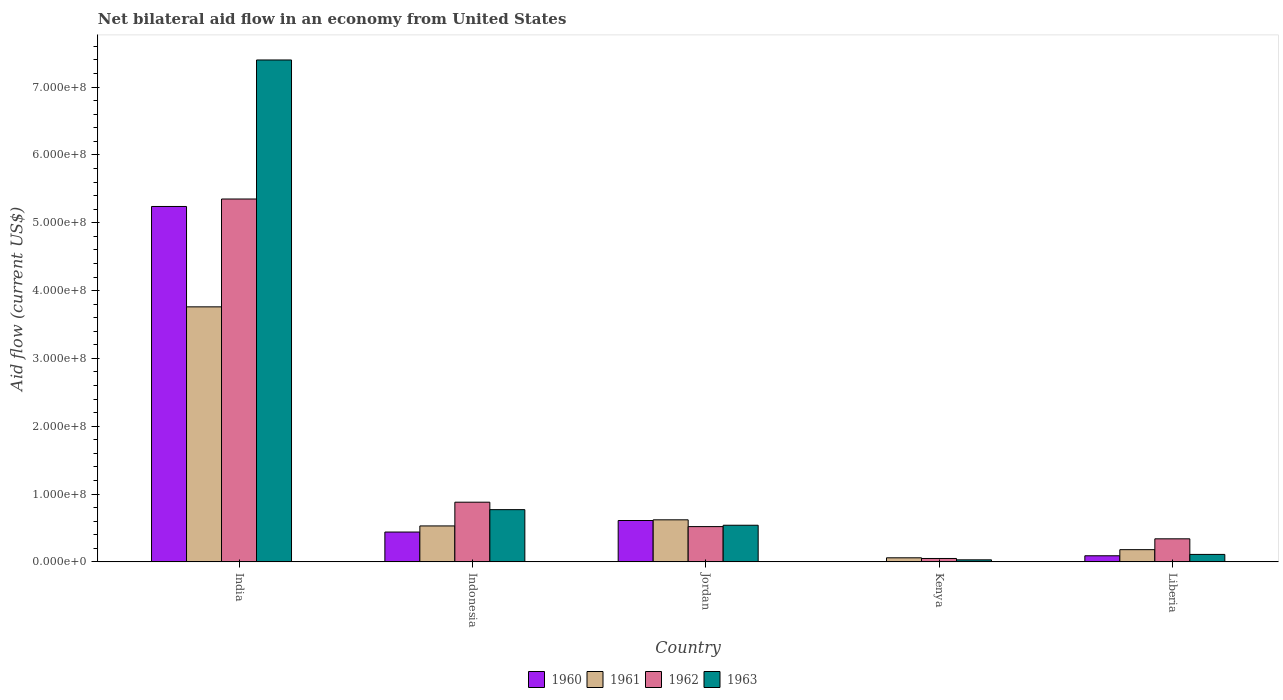How many groups of bars are there?
Keep it short and to the point. 5. Are the number of bars per tick equal to the number of legend labels?
Offer a very short reply. Yes. Are the number of bars on each tick of the X-axis equal?
Make the answer very short. Yes. How many bars are there on the 1st tick from the right?
Give a very brief answer. 4. What is the label of the 3rd group of bars from the left?
Keep it short and to the point. Jordan. What is the net bilateral aid flow in 1960 in India?
Your answer should be very brief. 5.24e+08. Across all countries, what is the maximum net bilateral aid flow in 1960?
Provide a succinct answer. 5.24e+08. Across all countries, what is the minimum net bilateral aid flow in 1962?
Provide a succinct answer. 5.00e+06. In which country was the net bilateral aid flow in 1961 maximum?
Keep it short and to the point. India. In which country was the net bilateral aid flow in 1962 minimum?
Make the answer very short. Kenya. What is the total net bilateral aid flow in 1962 in the graph?
Your answer should be very brief. 7.14e+08. What is the difference between the net bilateral aid flow in 1960 in India and that in Jordan?
Keep it short and to the point. 4.63e+08. What is the difference between the net bilateral aid flow in 1961 in Liberia and the net bilateral aid flow in 1962 in Jordan?
Offer a very short reply. -3.40e+07. What is the average net bilateral aid flow in 1963 per country?
Your answer should be compact. 1.77e+08. What is the difference between the net bilateral aid flow of/in 1962 and net bilateral aid flow of/in 1963 in Indonesia?
Offer a terse response. 1.10e+07. In how many countries, is the net bilateral aid flow in 1961 greater than 380000000 US$?
Keep it short and to the point. 0. What is the ratio of the net bilateral aid flow in 1961 in India to that in Liberia?
Provide a short and direct response. 20.89. Is the difference between the net bilateral aid flow in 1962 in India and Jordan greater than the difference between the net bilateral aid flow in 1963 in India and Jordan?
Provide a succinct answer. No. What is the difference between the highest and the second highest net bilateral aid flow in 1962?
Your answer should be very brief. 4.47e+08. What is the difference between the highest and the lowest net bilateral aid flow in 1963?
Your answer should be compact. 7.37e+08. In how many countries, is the net bilateral aid flow in 1960 greater than the average net bilateral aid flow in 1960 taken over all countries?
Provide a succinct answer. 1. Is the sum of the net bilateral aid flow in 1960 in Kenya and Liberia greater than the maximum net bilateral aid flow in 1962 across all countries?
Keep it short and to the point. No. Is it the case that in every country, the sum of the net bilateral aid flow in 1960 and net bilateral aid flow in 1961 is greater than the sum of net bilateral aid flow in 1963 and net bilateral aid flow in 1962?
Provide a succinct answer. No. What does the 4th bar from the left in Kenya represents?
Your response must be concise. 1963. Is it the case that in every country, the sum of the net bilateral aid flow in 1962 and net bilateral aid flow in 1961 is greater than the net bilateral aid flow in 1963?
Keep it short and to the point. Yes. Are all the bars in the graph horizontal?
Your response must be concise. No. What is the difference between two consecutive major ticks on the Y-axis?
Provide a short and direct response. 1.00e+08. Are the values on the major ticks of Y-axis written in scientific E-notation?
Make the answer very short. Yes. How many legend labels are there?
Give a very brief answer. 4. How are the legend labels stacked?
Provide a succinct answer. Horizontal. What is the title of the graph?
Your answer should be compact. Net bilateral aid flow in an economy from United States. What is the label or title of the X-axis?
Offer a terse response. Country. What is the label or title of the Y-axis?
Ensure brevity in your answer.  Aid flow (current US$). What is the Aid flow (current US$) of 1960 in India?
Your response must be concise. 5.24e+08. What is the Aid flow (current US$) of 1961 in India?
Provide a short and direct response. 3.76e+08. What is the Aid flow (current US$) of 1962 in India?
Provide a short and direct response. 5.35e+08. What is the Aid flow (current US$) in 1963 in India?
Make the answer very short. 7.40e+08. What is the Aid flow (current US$) in 1960 in Indonesia?
Offer a very short reply. 4.40e+07. What is the Aid flow (current US$) in 1961 in Indonesia?
Offer a very short reply. 5.30e+07. What is the Aid flow (current US$) of 1962 in Indonesia?
Make the answer very short. 8.80e+07. What is the Aid flow (current US$) in 1963 in Indonesia?
Your response must be concise. 7.70e+07. What is the Aid flow (current US$) in 1960 in Jordan?
Your answer should be compact. 6.10e+07. What is the Aid flow (current US$) of 1961 in Jordan?
Offer a terse response. 6.20e+07. What is the Aid flow (current US$) in 1962 in Jordan?
Offer a terse response. 5.20e+07. What is the Aid flow (current US$) in 1963 in Jordan?
Your answer should be very brief. 5.40e+07. What is the Aid flow (current US$) in 1960 in Kenya?
Provide a succinct answer. 4.80e+05. What is the Aid flow (current US$) in 1961 in Kenya?
Offer a very short reply. 6.00e+06. What is the Aid flow (current US$) of 1962 in Kenya?
Offer a very short reply. 5.00e+06. What is the Aid flow (current US$) of 1963 in Kenya?
Keep it short and to the point. 3.00e+06. What is the Aid flow (current US$) of 1960 in Liberia?
Your answer should be compact. 9.00e+06. What is the Aid flow (current US$) in 1961 in Liberia?
Your answer should be compact. 1.80e+07. What is the Aid flow (current US$) of 1962 in Liberia?
Make the answer very short. 3.40e+07. What is the Aid flow (current US$) of 1963 in Liberia?
Provide a succinct answer. 1.10e+07. Across all countries, what is the maximum Aid flow (current US$) of 1960?
Make the answer very short. 5.24e+08. Across all countries, what is the maximum Aid flow (current US$) of 1961?
Your response must be concise. 3.76e+08. Across all countries, what is the maximum Aid flow (current US$) in 1962?
Provide a short and direct response. 5.35e+08. Across all countries, what is the maximum Aid flow (current US$) of 1963?
Give a very brief answer. 7.40e+08. Across all countries, what is the minimum Aid flow (current US$) in 1961?
Provide a short and direct response. 6.00e+06. Across all countries, what is the minimum Aid flow (current US$) of 1963?
Provide a short and direct response. 3.00e+06. What is the total Aid flow (current US$) of 1960 in the graph?
Provide a short and direct response. 6.38e+08. What is the total Aid flow (current US$) in 1961 in the graph?
Give a very brief answer. 5.15e+08. What is the total Aid flow (current US$) in 1962 in the graph?
Your response must be concise. 7.14e+08. What is the total Aid flow (current US$) of 1963 in the graph?
Offer a terse response. 8.85e+08. What is the difference between the Aid flow (current US$) of 1960 in India and that in Indonesia?
Offer a very short reply. 4.80e+08. What is the difference between the Aid flow (current US$) of 1961 in India and that in Indonesia?
Provide a succinct answer. 3.23e+08. What is the difference between the Aid flow (current US$) in 1962 in India and that in Indonesia?
Provide a short and direct response. 4.47e+08. What is the difference between the Aid flow (current US$) in 1963 in India and that in Indonesia?
Offer a terse response. 6.63e+08. What is the difference between the Aid flow (current US$) in 1960 in India and that in Jordan?
Your answer should be very brief. 4.63e+08. What is the difference between the Aid flow (current US$) of 1961 in India and that in Jordan?
Offer a very short reply. 3.14e+08. What is the difference between the Aid flow (current US$) in 1962 in India and that in Jordan?
Your answer should be compact. 4.83e+08. What is the difference between the Aid flow (current US$) of 1963 in India and that in Jordan?
Provide a succinct answer. 6.86e+08. What is the difference between the Aid flow (current US$) in 1960 in India and that in Kenya?
Give a very brief answer. 5.24e+08. What is the difference between the Aid flow (current US$) in 1961 in India and that in Kenya?
Your response must be concise. 3.70e+08. What is the difference between the Aid flow (current US$) of 1962 in India and that in Kenya?
Ensure brevity in your answer.  5.30e+08. What is the difference between the Aid flow (current US$) of 1963 in India and that in Kenya?
Provide a succinct answer. 7.37e+08. What is the difference between the Aid flow (current US$) in 1960 in India and that in Liberia?
Keep it short and to the point. 5.15e+08. What is the difference between the Aid flow (current US$) of 1961 in India and that in Liberia?
Provide a succinct answer. 3.58e+08. What is the difference between the Aid flow (current US$) of 1962 in India and that in Liberia?
Your answer should be compact. 5.01e+08. What is the difference between the Aid flow (current US$) in 1963 in India and that in Liberia?
Your answer should be very brief. 7.29e+08. What is the difference between the Aid flow (current US$) in 1960 in Indonesia and that in Jordan?
Offer a terse response. -1.70e+07. What is the difference between the Aid flow (current US$) in 1961 in Indonesia and that in Jordan?
Your answer should be compact. -9.00e+06. What is the difference between the Aid flow (current US$) of 1962 in Indonesia and that in Jordan?
Ensure brevity in your answer.  3.60e+07. What is the difference between the Aid flow (current US$) of 1963 in Indonesia and that in Jordan?
Offer a terse response. 2.30e+07. What is the difference between the Aid flow (current US$) of 1960 in Indonesia and that in Kenya?
Your answer should be very brief. 4.35e+07. What is the difference between the Aid flow (current US$) in 1961 in Indonesia and that in Kenya?
Your answer should be very brief. 4.70e+07. What is the difference between the Aid flow (current US$) in 1962 in Indonesia and that in Kenya?
Keep it short and to the point. 8.30e+07. What is the difference between the Aid flow (current US$) of 1963 in Indonesia and that in Kenya?
Your answer should be compact. 7.40e+07. What is the difference between the Aid flow (current US$) in 1960 in Indonesia and that in Liberia?
Keep it short and to the point. 3.50e+07. What is the difference between the Aid flow (current US$) in 1961 in Indonesia and that in Liberia?
Your response must be concise. 3.50e+07. What is the difference between the Aid flow (current US$) in 1962 in Indonesia and that in Liberia?
Give a very brief answer. 5.40e+07. What is the difference between the Aid flow (current US$) in 1963 in Indonesia and that in Liberia?
Your response must be concise. 6.60e+07. What is the difference between the Aid flow (current US$) of 1960 in Jordan and that in Kenya?
Make the answer very short. 6.05e+07. What is the difference between the Aid flow (current US$) in 1961 in Jordan and that in Kenya?
Offer a very short reply. 5.60e+07. What is the difference between the Aid flow (current US$) in 1962 in Jordan and that in Kenya?
Your answer should be compact. 4.70e+07. What is the difference between the Aid flow (current US$) of 1963 in Jordan and that in Kenya?
Make the answer very short. 5.10e+07. What is the difference between the Aid flow (current US$) of 1960 in Jordan and that in Liberia?
Offer a terse response. 5.20e+07. What is the difference between the Aid flow (current US$) of 1961 in Jordan and that in Liberia?
Offer a terse response. 4.40e+07. What is the difference between the Aid flow (current US$) of 1962 in Jordan and that in Liberia?
Your response must be concise. 1.80e+07. What is the difference between the Aid flow (current US$) in 1963 in Jordan and that in Liberia?
Your answer should be very brief. 4.30e+07. What is the difference between the Aid flow (current US$) in 1960 in Kenya and that in Liberia?
Make the answer very short. -8.52e+06. What is the difference between the Aid flow (current US$) of 1961 in Kenya and that in Liberia?
Offer a very short reply. -1.20e+07. What is the difference between the Aid flow (current US$) in 1962 in Kenya and that in Liberia?
Make the answer very short. -2.90e+07. What is the difference between the Aid flow (current US$) in 1963 in Kenya and that in Liberia?
Provide a short and direct response. -8.00e+06. What is the difference between the Aid flow (current US$) in 1960 in India and the Aid flow (current US$) in 1961 in Indonesia?
Provide a short and direct response. 4.71e+08. What is the difference between the Aid flow (current US$) of 1960 in India and the Aid flow (current US$) of 1962 in Indonesia?
Your answer should be compact. 4.36e+08. What is the difference between the Aid flow (current US$) in 1960 in India and the Aid flow (current US$) in 1963 in Indonesia?
Give a very brief answer. 4.47e+08. What is the difference between the Aid flow (current US$) in 1961 in India and the Aid flow (current US$) in 1962 in Indonesia?
Make the answer very short. 2.88e+08. What is the difference between the Aid flow (current US$) of 1961 in India and the Aid flow (current US$) of 1963 in Indonesia?
Offer a terse response. 2.99e+08. What is the difference between the Aid flow (current US$) of 1962 in India and the Aid flow (current US$) of 1963 in Indonesia?
Make the answer very short. 4.58e+08. What is the difference between the Aid flow (current US$) in 1960 in India and the Aid flow (current US$) in 1961 in Jordan?
Ensure brevity in your answer.  4.62e+08. What is the difference between the Aid flow (current US$) in 1960 in India and the Aid flow (current US$) in 1962 in Jordan?
Offer a very short reply. 4.72e+08. What is the difference between the Aid flow (current US$) of 1960 in India and the Aid flow (current US$) of 1963 in Jordan?
Offer a terse response. 4.70e+08. What is the difference between the Aid flow (current US$) of 1961 in India and the Aid flow (current US$) of 1962 in Jordan?
Offer a terse response. 3.24e+08. What is the difference between the Aid flow (current US$) in 1961 in India and the Aid flow (current US$) in 1963 in Jordan?
Your response must be concise. 3.22e+08. What is the difference between the Aid flow (current US$) of 1962 in India and the Aid flow (current US$) of 1963 in Jordan?
Keep it short and to the point. 4.81e+08. What is the difference between the Aid flow (current US$) of 1960 in India and the Aid flow (current US$) of 1961 in Kenya?
Make the answer very short. 5.18e+08. What is the difference between the Aid flow (current US$) in 1960 in India and the Aid flow (current US$) in 1962 in Kenya?
Provide a short and direct response. 5.19e+08. What is the difference between the Aid flow (current US$) in 1960 in India and the Aid flow (current US$) in 1963 in Kenya?
Offer a terse response. 5.21e+08. What is the difference between the Aid flow (current US$) of 1961 in India and the Aid flow (current US$) of 1962 in Kenya?
Provide a succinct answer. 3.71e+08. What is the difference between the Aid flow (current US$) in 1961 in India and the Aid flow (current US$) in 1963 in Kenya?
Provide a short and direct response. 3.73e+08. What is the difference between the Aid flow (current US$) of 1962 in India and the Aid flow (current US$) of 1963 in Kenya?
Provide a short and direct response. 5.32e+08. What is the difference between the Aid flow (current US$) in 1960 in India and the Aid flow (current US$) in 1961 in Liberia?
Your answer should be very brief. 5.06e+08. What is the difference between the Aid flow (current US$) in 1960 in India and the Aid flow (current US$) in 1962 in Liberia?
Provide a short and direct response. 4.90e+08. What is the difference between the Aid flow (current US$) of 1960 in India and the Aid flow (current US$) of 1963 in Liberia?
Offer a very short reply. 5.13e+08. What is the difference between the Aid flow (current US$) of 1961 in India and the Aid flow (current US$) of 1962 in Liberia?
Keep it short and to the point. 3.42e+08. What is the difference between the Aid flow (current US$) of 1961 in India and the Aid flow (current US$) of 1963 in Liberia?
Keep it short and to the point. 3.65e+08. What is the difference between the Aid flow (current US$) of 1962 in India and the Aid flow (current US$) of 1963 in Liberia?
Offer a terse response. 5.24e+08. What is the difference between the Aid flow (current US$) in 1960 in Indonesia and the Aid flow (current US$) in 1961 in Jordan?
Ensure brevity in your answer.  -1.80e+07. What is the difference between the Aid flow (current US$) of 1960 in Indonesia and the Aid flow (current US$) of 1962 in Jordan?
Offer a very short reply. -8.00e+06. What is the difference between the Aid flow (current US$) of 1960 in Indonesia and the Aid flow (current US$) of 1963 in Jordan?
Provide a short and direct response. -1.00e+07. What is the difference between the Aid flow (current US$) of 1961 in Indonesia and the Aid flow (current US$) of 1962 in Jordan?
Offer a very short reply. 1.00e+06. What is the difference between the Aid flow (current US$) of 1961 in Indonesia and the Aid flow (current US$) of 1963 in Jordan?
Keep it short and to the point. -1.00e+06. What is the difference between the Aid flow (current US$) in 1962 in Indonesia and the Aid flow (current US$) in 1963 in Jordan?
Make the answer very short. 3.40e+07. What is the difference between the Aid flow (current US$) of 1960 in Indonesia and the Aid flow (current US$) of 1961 in Kenya?
Your answer should be compact. 3.80e+07. What is the difference between the Aid flow (current US$) in 1960 in Indonesia and the Aid flow (current US$) in 1962 in Kenya?
Your response must be concise. 3.90e+07. What is the difference between the Aid flow (current US$) in 1960 in Indonesia and the Aid flow (current US$) in 1963 in Kenya?
Keep it short and to the point. 4.10e+07. What is the difference between the Aid flow (current US$) in 1961 in Indonesia and the Aid flow (current US$) in 1962 in Kenya?
Offer a very short reply. 4.80e+07. What is the difference between the Aid flow (current US$) in 1961 in Indonesia and the Aid flow (current US$) in 1963 in Kenya?
Your answer should be very brief. 5.00e+07. What is the difference between the Aid flow (current US$) in 1962 in Indonesia and the Aid flow (current US$) in 1963 in Kenya?
Your response must be concise. 8.50e+07. What is the difference between the Aid flow (current US$) in 1960 in Indonesia and the Aid flow (current US$) in 1961 in Liberia?
Make the answer very short. 2.60e+07. What is the difference between the Aid flow (current US$) in 1960 in Indonesia and the Aid flow (current US$) in 1963 in Liberia?
Make the answer very short. 3.30e+07. What is the difference between the Aid flow (current US$) in 1961 in Indonesia and the Aid flow (current US$) in 1962 in Liberia?
Give a very brief answer. 1.90e+07. What is the difference between the Aid flow (current US$) of 1961 in Indonesia and the Aid flow (current US$) of 1963 in Liberia?
Provide a succinct answer. 4.20e+07. What is the difference between the Aid flow (current US$) in 1962 in Indonesia and the Aid flow (current US$) in 1963 in Liberia?
Give a very brief answer. 7.70e+07. What is the difference between the Aid flow (current US$) of 1960 in Jordan and the Aid flow (current US$) of 1961 in Kenya?
Your answer should be very brief. 5.50e+07. What is the difference between the Aid flow (current US$) in 1960 in Jordan and the Aid flow (current US$) in 1962 in Kenya?
Ensure brevity in your answer.  5.60e+07. What is the difference between the Aid flow (current US$) of 1960 in Jordan and the Aid flow (current US$) of 1963 in Kenya?
Ensure brevity in your answer.  5.80e+07. What is the difference between the Aid flow (current US$) in 1961 in Jordan and the Aid flow (current US$) in 1962 in Kenya?
Offer a terse response. 5.70e+07. What is the difference between the Aid flow (current US$) in 1961 in Jordan and the Aid flow (current US$) in 1963 in Kenya?
Provide a short and direct response. 5.90e+07. What is the difference between the Aid flow (current US$) in 1962 in Jordan and the Aid flow (current US$) in 1963 in Kenya?
Offer a very short reply. 4.90e+07. What is the difference between the Aid flow (current US$) of 1960 in Jordan and the Aid flow (current US$) of 1961 in Liberia?
Ensure brevity in your answer.  4.30e+07. What is the difference between the Aid flow (current US$) of 1960 in Jordan and the Aid flow (current US$) of 1962 in Liberia?
Your response must be concise. 2.70e+07. What is the difference between the Aid flow (current US$) in 1960 in Jordan and the Aid flow (current US$) in 1963 in Liberia?
Ensure brevity in your answer.  5.00e+07. What is the difference between the Aid flow (current US$) in 1961 in Jordan and the Aid flow (current US$) in 1962 in Liberia?
Provide a succinct answer. 2.80e+07. What is the difference between the Aid flow (current US$) of 1961 in Jordan and the Aid flow (current US$) of 1963 in Liberia?
Give a very brief answer. 5.10e+07. What is the difference between the Aid flow (current US$) of 1962 in Jordan and the Aid flow (current US$) of 1963 in Liberia?
Ensure brevity in your answer.  4.10e+07. What is the difference between the Aid flow (current US$) in 1960 in Kenya and the Aid flow (current US$) in 1961 in Liberia?
Give a very brief answer. -1.75e+07. What is the difference between the Aid flow (current US$) of 1960 in Kenya and the Aid flow (current US$) of 1962 in Liberia?
Your response must be concise. -3.35e+07. What is the difference between the Aid flow (current US$) of 1960 in Kenya and the Aid flow (current US$) of 1963 in Liberia?
Provide a short and direct response. -1.05e+07. What is the difference between the Aid flow (current US$) of 1961 in Kenya and the Aid flow (current US$) of 1962 in Liberia?
Your answer should be compact. -2.80e+07. What is the difference between the Aid flow (current US$) in 1961 in Kenya and the Aid flow (current US$) in 1963 in Liberia?
Your answer should be very brief. -5.00e+06. What is the difference between the Aid flow (current US$) in 1962 in Kenya and the Aid flow (current US$) in 1963 in Liberia?
Make the answer very short. -6.00e+06. What is the average Aid flow (current US$) of 1960 per country?
Ensure brevity in your answer.  1.28e+08. What is the average Aid flow (current US$) in 1961 per country?
Provide a short and direct response. 1.03e+08. What is the average Aid flow (current US$) in 1962 per country?
Ensure brevity in your answer.  1.43e+08. What is the average Aid flow (current US$) of 1963 per country?
Make the answer very short. 1.77e+08. What is the difference between the Aid flow (current US$) of 1960 and Aid flow (current US$) of 1961 in India?
Offer a terse response. 1.48e+08. What is the difference between the Aid flow (current US$) of 1960 and Aid flow (current US$) of 1962 in India?
Your answer should be compact. -1.10e+07. What is the difference between the Aid flow (current US$) of 1960 and Aid flow (current US$) of 1963 in India?
Provide a succinct answer. -2.16e+08. What is the difference between the Aid flow (current US$) of 1961 and Aid flow (current US$) of 1962 in India?
Your response must be concise. -1.59e+08. What is the difference between the Aid flow (current US$) in 1961 and Aid flow (current US$) in 1963 in India?
Your answer should be very brief. -3.64e+08. What is the difference between the Aid flow (current US$) of 1962 and Aid flow (current US$) of 1963 in India?
Provide a short and direct response. -2.05e+08. What is the difference between the Aid flow (current US$) of 1960 and Aid flow (current US$) of 1961 in Indonesia?
Your response must be concise. -9.00e+06. What is the difference between the Aid flow (current US$) of 1960 and Aid flow (current US$) of 1962 in Indonesia?
Provide a short and direct response. -4.40e+07. What is the difference between the Aid flow (current US$) of 1960 and Aid flow (current US$) of 1963 in Indonesia?
Make the answer very short. -3.30e+07. What is the difference between the Aid flow (current US$) of 1961 and Aid flow (current US$) of 1962 in Indonesia?
Offer a very short reply. -3.50e+07. What is the difference between the Aid flow (current US$) in 1961 and Aid flow (current US$) in 1963 in Indonesia?
Make the answer very short. -2.40e+07. What is the difference between the Aid flow (current US$) in 1962 and Aid flow (current US$) in 1963 in Indonesia?
Your answer should be compact. 1.10e+07. What is the difference between the Aid flow (current US$) in 1960 and Aid flow (current US$) in 1962 in Jordan?
Make the answer very short. 9.00e+06. What is the difference between the Aid flow (current US$) of 1961 and Aid flow (current US$) of 1962 in Jordan?
Provide a short and direct response. 1.00e+07. What is the difference between the Aid flow (current US$) of 1961 and Aid flow (current US$) of 1963 in Jordan?
Your answer should be compact. 8.00e+06. What is the difference between the Aid flow (current US$) in 1960 and Aid flow (current US$) in 1961 in Kenya?
Give a very brief answer. -5.52e+06. What is the difference between the Aid flow (current US$) of 1960 and Aid flow (current US$) of 1962 in Kenya?
Keep it short and to the point. -4.52e+06. What is the difference between the Aid flow (current US$) in 1960 and Aid flow (current US$) in 1963 in Kenya?
Make the answer very short. -2.52e+06. What is the difference between the Aid flow (current US$) in 1961 and Aid flow (current US$) in 1962 in Kenya?
Your answer should be compact. 1.00e+06. What is the difference between the Aid flow (current US$) in 1962 and Aid flow (current US$) in 1963 in Kenya?
Your answer should be very brief. 2.00e+06. What is the difference between the Aid flow (current US$) of 1960 and Aid flow (current US$) of 1961 in Liberia?
Provide a short and direct response. -9.00e+06. What is the difference between the Aid flow (current US$) in 1960 and Aid flow (current US$) in 1962 in Liberia?
Ensure brevity in your answer.  -2.50e+07. What is the difference between the Aid flow (current US$) of 1960 and Aid flow (current US$) of 1963 in Liberia?
Your answer should be very brief. -2.00e+06. What is the difference between the Aid flow (current US$) in 1961 and Aid flow (current US$) in 1962 in Liberia?
Give a very brief answer. -1.60e+07. What is the difference between the Aid flow (current US$) in 1961 and Aid flow (current US$) in 1963 in Liberia?
Offer a terse response. 7.00e+06. What is the difference between the Aid flow (current US$) in 1962 and Aid flow (current US$) in 1963 in Liberia?
Your answer should be compact. 2.30e+07. What is the ratio of the Aid flow (current US$) in 1960 in India to that in Indonesia?
Offer a terse response. 11.91. What is the ratio of the Aid flow (current US$) in 1961 in India to that in Indonesia?
Keep it short and to the point. 7.09. What is the ratio of the Aid flow (current US$) in 1962 in India to that in Indonesia?
Your answer should be compact. 6.08. What is the ratio of the Aid flow (current US$) of 1963 in India to that in Indonesia?
Give a very brief answer. 9.61. What is the ratio of the Aid flow (current US$) of 1960 in India to that in Jordan?
Your answer should be compact. 8.59. What is the ratio of the Aid flow (current US$) of 1961 in India to that in Jordan?
Offer a very short reply. 6.06. What is the ratio of the Aid flow (current US$) of 1962 in India to that in Jordan?
Make the answer very short. 10.29. What is the ratio of the Aid flow (current US$) of 1963 in India to that in Jordan?
Keep it short and to the point. 13.7. What is the ratio of the Aid flow (current US$) in 1960 in India to that in Kenya?
Give a very brief answer. 1091.67. What is the ratio of the Aid flow (current US$) in 1961 in India to that in Kenya?
Provide a succinct answer. 62.67. What is the ratio of the Aid flow (current US$) in 1962 in India to that in Kenya?
Give a very brief answer. 107. What is the ratio of the Aid flow (current US$) of 1963 in India to that in Kenya?
Offer a terse response. 246.67. What is the ratio of the Aid flow (current US$) of 1960 in India to that in Liberia?
Your response must be concise. 58.22. What is the ratio of the Aid flow (current US$) in 1961 in India to that in Liberia?
Keep it short and to the point. 20.89. What is the ratio of the Aid flow (current US$) of 1962 in India to that in Liberia?
Your response must be concise. 15.74. What is the ratio of the Aid flow (current US$) in 1963 in India to that in Liberia?
Offer a very short reply. 67.27. What is the ratio of the Aid flow (current US$) of 1960 in Indonesia to that in Jordan?
Make the answer very short. 0.72. What is the ratio of the Aid flow (current US$) in 1961 in Indonesia to that in Jordan?
Provide a short and direct response. 0.85. What is the ratio of the Aid flow (current US$) in 1962 in Indonesia to that in Jordan?
Provide a short and direct response. 1.69. What is the ratio of the Aid flow (current US$) of 1963 in Indonesia to that in Jordan?
Provide a short and direct response. 1.43. What is the ratio of the Aid flow (current US$) of 1960 in Indonesia to that in Kenya?
Ensure brevity in your answer.  91.67. What is the ratio of the Aid flow (current US$) in 1961 in Indonesia to that in Kenya?
Provide a short and direct response. 8.83. What is the ratio of the Aid flow (current US$) in 1963 in Indonesia to that in Kenya?
Provide a succinct answer. 25.67. What is the ratio of the Aid flow (current US$) in 1960 in Indonesia to that in Liberia?
Provide a short and direct response. 4.89. What is the ratio of the Aid flow (current US$) in 1961 in Indonesia to that in Liberia?
Give a very brief answer. 2.94. What is the ratio of the Aid flow (current US$) of 1962 in Indonesia to that in Liberia?
Offer a very short reply. 2.59. What is the ratio of the Aid flow (current US$) of 1963 in Indonesia to that in Liberia?
Give a very brief answer. 7. What is the ratio of the Aid flow (current US$) in 1960 in Jordan to that in Kenya?
Provide a short and direct response. 127.08. What is the ratio of the Aid flow (current US$) in 1961 in Jordan to that in Kenya?
Provide a succinct answer. 10.33. What is the ratio of the Aid flow (current US$) of 1960 in Jordan to that in Liberia?
Make the answer very short. 6.78. What is the ratio of the Aid flow (current US$) of 1961 in Jordan to that in Liberia?
Provide a short and direct response. 3.44. What is the ratio of the Aid flow (current US$) in 1962 in Jordan to that in Liberia?
Give a very brief answer. 1.53. What is the ratio of the Aid flow (current US$) of 1963 in Jordan to that in Liberia?
Ensure brevity in your answer.  4.91. What is the ratio of the Aid flow (current US$) of 1960 in Kenya to that in Liberia?
Keep it short and to the point. 0.05. What is the ratio of the Aid flow (current US$) of 1962 in Kenya to that in Liberia?
Offer a terse response. 0.15. What is the ratio of the Aid flow (current US$) of 1963 in Kenya to that in Liberia?
Make the answer very short. 0.27. What is the difference between the highest and the second highest Aid flow (current US$) in 1960?
Make the answer very short. 4.63e+08. What is the difference between the highest and the second highest Aid flow (current US$) of 1961?
Offer a terse response. 3.14e+08. What is the difference between the highest and the second highest Aid flow (current US$) of 1962?
Provide a short and direct response. 4.47e+08. What is the difference between the highest and the second highest Aid flow (current US$) in 1963?
Make the answer very short. 6.63e+08. What is the difference between the highest and the lowest Aid flow (current US$) of 1960?
Provide a short and direct response. 5.24e+08. What is the difference between the highest and the lowest Aid flow (current US$) of 1961?
Ensure brevity in your answer.  3.70e+08. What is the difference between the highest and the lowest Aid flow (current US$) in 1962?
Your answer should be compact. 5.30e+08. What is the difference between the highest and the lowest Aid flow (current US$) in 1963?
Your answer should be compact. 7.37e+08. 